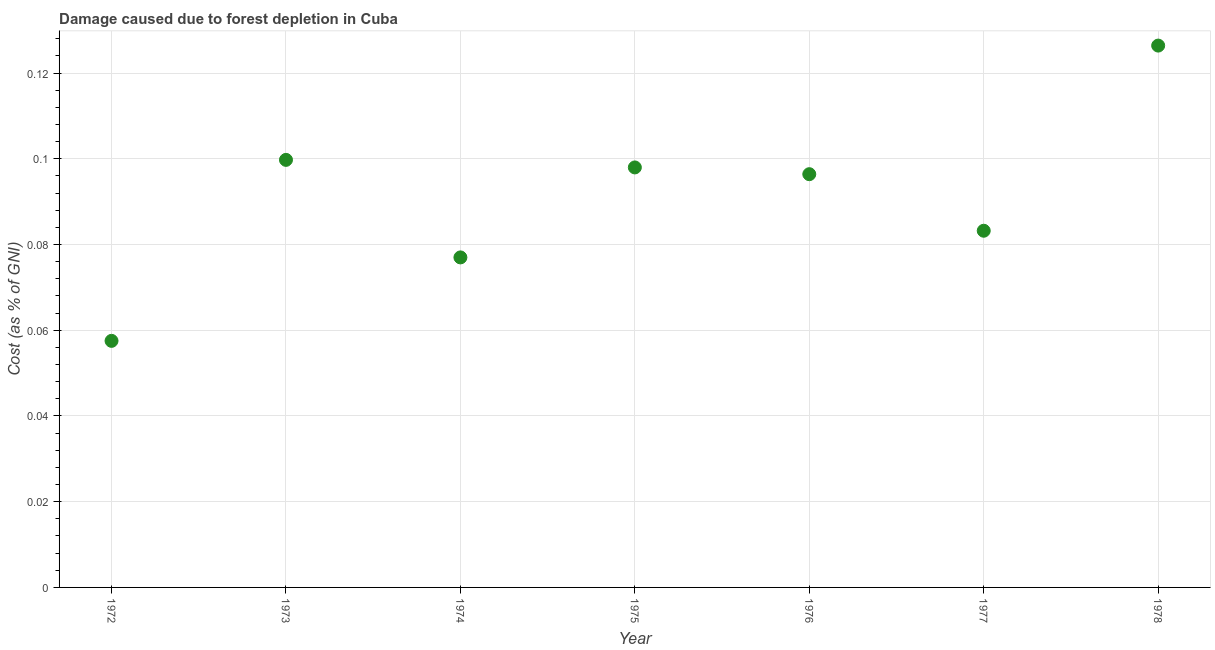What is the damage caused due to forest depletion in 1972?
Provide a succinct answer. 0.06. Across all years, what is the maximum damage caused due to forest depletion?
Ensure brevity in your answer.  0.13. Across all years, what is the minimum damage caused due to forest depletion?
Offer a very short reply. 0.06. In which year was the damage caused due to forest depletion maximum?
Your response must be concise. 1978. What is the sum of the damage caused due to forest depletion?
Provide a succinct answer. 0.64. What is the difference between the damage caused due to forest depletion in 1974 and 1976?
Offer a terse response. -0.02. What is the average damage caused due to forest depletion per year?
Give a very brief answer. 0.09. What is the median damage caused due to forest depletion?
Your response must be concise. 0.1. In how many years, is the damage caused due to forest depletion greater than 0.124 %?
Provide a short and direct response. 1. Do a majority of the years between 1976 and 1974 (inclusive) have damage caused due to forest depletion greater than 0.056 %?
Ensure brevity in your answer.  No. What is the ratio of the damage caused due to forest depletion in 1972 to that in 1973?
Give a very brief answer. 0.58. What is the difference between the highest and the second highest damage caused due to forest depletion?
Your response must be concise. 0.03. Is the sum of the damage caused due to forest depletion in 1972 and 1977 greater than the maximum damage caused due to forest depletion across all years?
Give a very brief answer. Yes. What is the difference between the highest and the lowest damage caused due to forest depletion?
Your answer should be compact. 0.07. In how many years, is the damage caused due to forest depletion greater than the average damage caused due to forest depletion taken over all years?
Your response must be concise. 4. How many dotlines are there?
Ensure brevity in your answer.  1. How many years are there in the graph?
Provide a succinct answer. 7. What is the difference between two consecutive major ticks on the Y-axis?
Provide a short and direct response. 0.02. Does the graph contain any zero values?
Make the answer very short. No. Does the graph contain grids?
Ensure brevity in your answer.  Yes. What is the title of the graph?
Keep it short and to the point. Damage caused due to forest depletion in Cuba. What is the label or title of the Y-axis?
Offer a terse response. Cost (as % of GNI). What is the Cost (as % of GNI) in 1972?
Your response must be concise. 0.06. What is the Cost (as % of GNI) in 1973?
Your answer should be compact. 0.1. What is the Cost (as % of GNI) in 1974?
Keep it short and to the point. 0.08. What is the Cost (as % of GNI) in 1975?
Offer a very short reply. 0.1. What is the Cost (as % of GNI) in 1976?
Offer a terse response. 0.1. What is the Cost (as % of GNI) in 1977?
Offer a terse response. 0.08. What is the Cost (as % of GNI) in 1978?
Provide a succinct answer. 0.13. What is the difference between the Cost (as % of GNI) in 1972 and 1973?
Your response must be concise. -0.04. What is the difference between the Cost (as % of GNI) in 1972 and 1974?
Give a very brief answer. -0.02. What is the difference between the Cost (as % of GNI) in 1972 and 1975?
Offer a terse response. -0.04. What is the difference between the Cost (as % of GNI) in 1972 and 1976?
Your answer should be very brief. -0.04. What is the difference between the Cost (as % of GNI) in 1972 and 1977?
Your answer should be very brief. -0.03. What is the difference between the Cost (as % of GNI) in 1972 and 1978?
Make the answer very short. -0.07. What is the difference between the Cost (as % of GNI) in 1973 and 1974?
Your answer should be compact. 0.02. What is the difference between the Cost (as % of GNI) in 1973 and 1975?
Give a very brief answer. 0. What is the difference between the Cost (as % of GNI) in 1973 and 1976?
Offer a terse response. 0. What is the difference between the Cost (as % of GNI) in 1973 and 1977?
Your answer should be compact. 0.02. What is the difference between the Cost (as % of GNI) in 1973 and 1978?
Give a very brief answer. -0.03. What is the difference between the Cost (as % of GNI) in 1974 and 1975?
Your response must be concise. -0.02. What is the difference between the Cost (as % of GNI) in 1974 and 1976?
Ensure brevity in your answer.  -0.02. What is the difference between the Cost (as % of GNI) in 1974 and 1977?
Offer a very short reply. -0.01. What is the difference between the Cost (as % of GNI) in 1974 and 1978?
Offer a very short reply. -0.05. What is the difference between the Cost (as % of GNI) in 1975 and 1976?
Ensure brevity in your answer.  0. What is the difference between the Cost (as % of GNI) in 1975 and 1977?
Offer a terse response. 0.01. What is the difference between the Cost (as % of GNI) in 1975 and 1978?
Provide a succinct answer. -0.03. What is the difference between the Cost (as % of GNI) in 1976 and 1977?
Your response must be concise. 0.01. What is the difference between the Cost (as % of GNI) in 1976 and 1978?
Provide a short and direct response. -0.03. What is the difference between the Cost (as % of GNI) in 1977 and 1978?
Offer a very short reply. -0.04. What is the ratio of the Cost (as % of GNI) in 1972 to that in 1973?
Ensure brevity in your answer.  0.58. What is the ratio of the Cost (as % of GNI) in 1972 to that in 1974?
Provide a succinct answer. 0.75. What is the ratio of the Cost (as % of GNI) in 1972 to that in 1975?
Make the answer very short. 0.59. What is the ratio of the Cost (as % of GNI) in 1972 to that in 1976?
Your answer should be compact. 0.6. What is the ratio of the Cost (as % of GNI) in 1972 to that in 1977?
Your answer should be compact. 0.69. What is the ratio of the Cost (as % of GNI) in 1972 to that in 1978?
Your response must be concise. 0.46. What is the ratio of the Cost (as % of GNI) in 1973 to that in 1974?
Offer a very short reply. 1.3. What is the ratio of the Cost (as % of GNI) in 1973 to that in 1975?
Ensure brevity in your answer.  1.02. What is the ratio of the Cost (as % of GNI) in 1973 to that in 1976?
Offer a terse response. 1.03. What is the ratio of the Cost (as % of GNI) in 1973 to that in 1977?
Keep it short and to the point. 1.2. What is the ratio of the Cost (as % of GNI) in 1973 to that in 1978?
Offer a very short reply. 0.79. What is the ratio of the Cost (as % of GNI) in 1974 to that in 1975?
Offer a very short reply. 0.79. What is the ratio of the Cost (as % of GNI) in 1974 to that in 1976?
Offer a terse response. 0.8. What is the ratio of the Cost (as % of GNI) in 1974 to that in 1977?
Give a very brief answer. 0.93. What is the ratio of the Cost (as % of GNI) in 1974 to that in 1978?
Keep it short and to the point. 0.61. What is the ratio of the Cost (as % of GNI) in 1975 to that in 1977?
Offer a very short reply. 1.18. What is the ratio of the Cost (as % of GNI) in 1975 to that in 1978?
Provide a short and direct response. 0.78. What is the ratio of the Cost (as % of GNI) in 1976 to that in 1977?
Offer a terse response. 1.16. What is the ratio of the Cost (as % of GNI) in 1976 to that in 1978?
Give a very brief answer. 0.76. What is the ratio of the Cost (as % of GNI) in 1977 to that in 1978?
Keep it short and to the point. 0.66. 